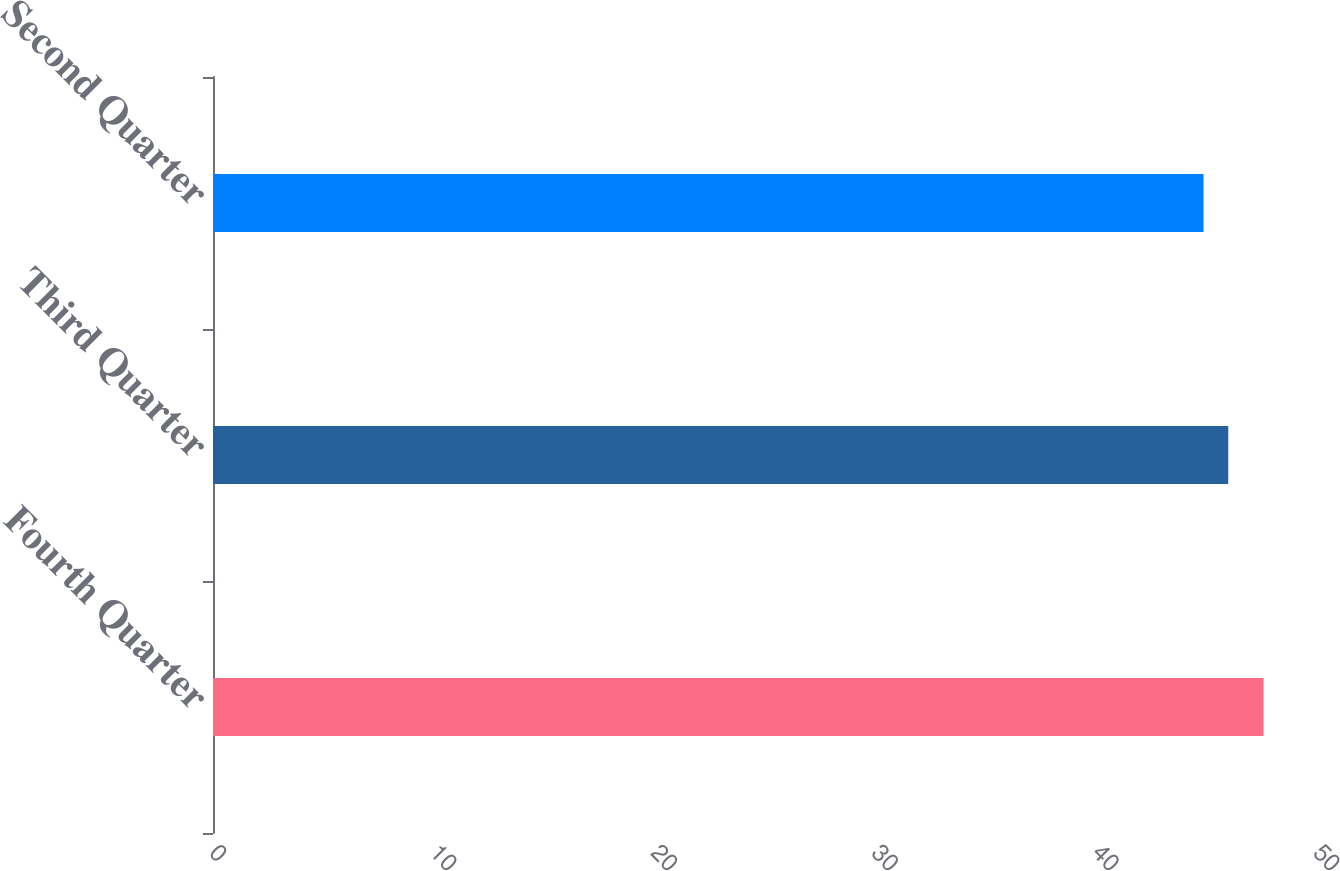<chart> <loc_0><loc_0><loc_500><loc_500><bar_chart><fcel>Fourth Quarter<fcel>Third Quarter<fcel>Second Quarter<nl><fcel>47.58<fcel>45.98<fcel>44.86<nl></chart> 